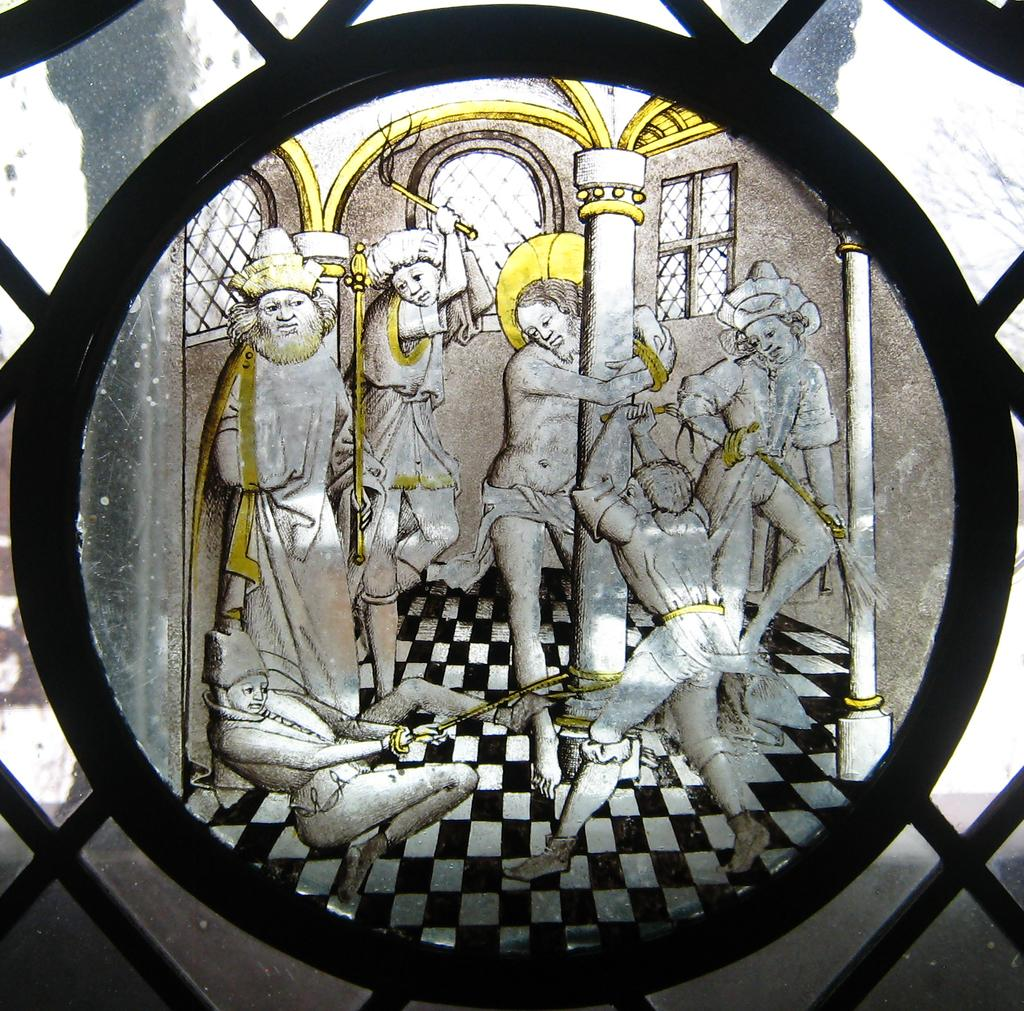What type of structure is present in the image? There is a glass window in the picture. Is there any artwork on the window? Yes, there is a painting on the window. What is the subject matter of the painting? The painting depicts people hitting one person. What is the manager's reaction to the situation depicted in the painting? There is no manager present in the image, and the painting does not depict a reaction. 